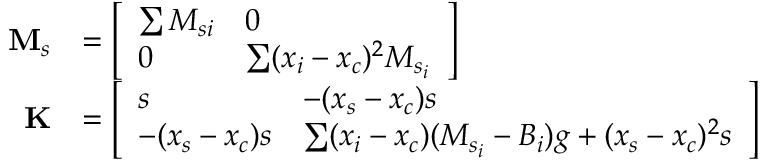Convert formula to latex. <formula><loc_0><loc_0><loc_500><loc_500>\begin{array} { r l } { M _ { s } } & { = \left [ \begin{array} { l l } { \sum M _ { s i } } & { 0 } \\ { 0 } & { \sum ( x _ { i } - x _ { c } ) ^ { 2 } M _ { s _ { i } } } \end{array} \right ] } \\ { K } & { = \left [ \begin{array} { l l } { s } & { - ( x _ { s } - x _ { c } ) s } \\ { - ( x _ { s } - x _ { c } ) s } & { \sum ( x _ { i } - x _ { c } ) ( M _ { s _ { i } } - B _ { i } ) g + ( x _ { s } - x _ { c } ) ^ { 2 } s } \end{array} \right ] } \end{array}</formula> 